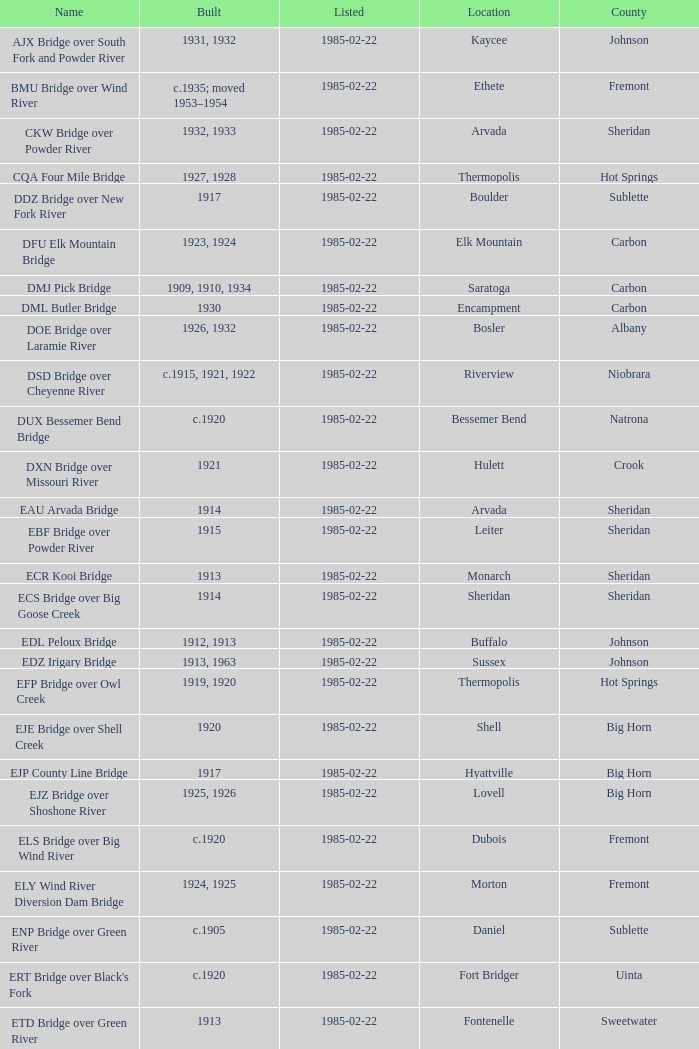What bridge in Sheridan county was built in 1915? EBF Bridge over Powder River. Give me the full table as a dictionary. {'header': ['Name', 'Built', 'Listed', 'Location', 'County'], 'rows': [['AJX Bridge over South Fork and Powder River', '1931, 1932', '1985-02-22', 'Kaycee', 'Johnson'], ['BMU Bridge over Wind River', 'c.1935; moved 1953–1954', '1985-02-22', 'Ethete', 'Fremont'], ['CKW Bridge over Powder River', '1932, 1933', '1985-02-22', 'Arvada', 'Sheridan'], ['CQA Four Mile Bridge', '1927, 1928', '1985-02-22', 'Thermopolis', 'Hot Springs'], ['DDZ Bridge over New Fork River', '1917', '1985-02-22', 'Boulder', 'Sublette'], ['DFU Elk Mountain Bridge', '1923, 1924', '1985-02-22', 'Elk Mountain', 'Carbon'], ['DMJ Pick Bridge', '1909, 1910, 1934', '1985-02-22', 'Saratoga', 'Carbon'], ['DML Butler Bridge', '1930', '1985-02-22', 'Encampment', 'Carbon'], ['DOE Bridge over Laramie River', '1926, 1932', '1985-02-22', 'Bosler', 'Albany'], ['DSD Bridge over Cheyenne River', 'c.1915, 1921, 1922', '1985-02-22', 'Riverview', 'Niobrara'], ['DUX Bessemer Bend Bridge', 'c.1920', '1985-02-22', 'Bessemer Bend', 'Natrona'], ['DXN Bridge over Missouri River', '1921', '1985-02-22', 'Hulett', 'Crook'], ['EAU Arvada Bridge', '1914', '1985-02-22', 'Arvada', 'Sheridan'], ['EBF Bridge over Powder River', '1915', '1985-02-22', 'Leiter', 'Sheridan'], ['ECR Kooi Bridge', '1913', '1985-02-22', 'Monarch', 'Sheridan'], ['ECS Bridge over Big Goose Creek', '1914', '1985-02-22', 'Sheridan', 'Sheridan'], ['EDL Peloux Bridge', '1912, 1913', '1985-02-22', 'Buffalo', 'Johnson'], ['EDZ Irigary Bridge', '1913, 1963', '1985-02-22', 'Sussex', 'Johnson'], ['EFP Bridge over Owl Creek', '1919, 1920', '1985-02-22', 'Thermopolis', 'Hot Springs'], ['EJE Bridge over Shell Creek', '1920', '1985-02-22', 'Shell', 'Big Horn'], ['EJP County Line Bridge', '1917', '1985-02-22', 'Hyattville', 'Big Horn'], ['EJZ Bridge over Shoshone River', '1925, 1926', '1985-02-22', 'Lovell', 'Big Horn'], ['ELS Bridge over Big Wind River', 'c.1920', '1985-02-22', 'Dubois', 'Fremont'], ['ELY Wind River Diversion Dam Bridge', '1924, 1925', '1985-02-22', 'Morton', 'Fremont'], ['ENP Bridge over Green River', 'c.1905', '1985-02-22', 'Daniel', 'Sublette'], ["ERT Bridge over Black's Fork", 'c.1920', '1985-02-22', 'Fort Bridger', 'Uinta'], ['ETD Bridge over Green River', '1913', '1985-02-22', 'Fontenelle', 'Sweetwater'], ['ETR Big Island Bridge', '1909, 1910', '1985-02-22', 'Green River', 'Sweetwater'], ['EWZ Bridge over East Channel of Laramie River', '1913, 1914', '1985-02-22', 'Wheatland', 'Platte'], ['Hayden Arch Bridge', '1924, 1925', '1985-02-22', 'Cody', 'Park'], ['Rairden Bridge', '1916', '1985-02-22', 'Manderson', 'Big Horn']]} 